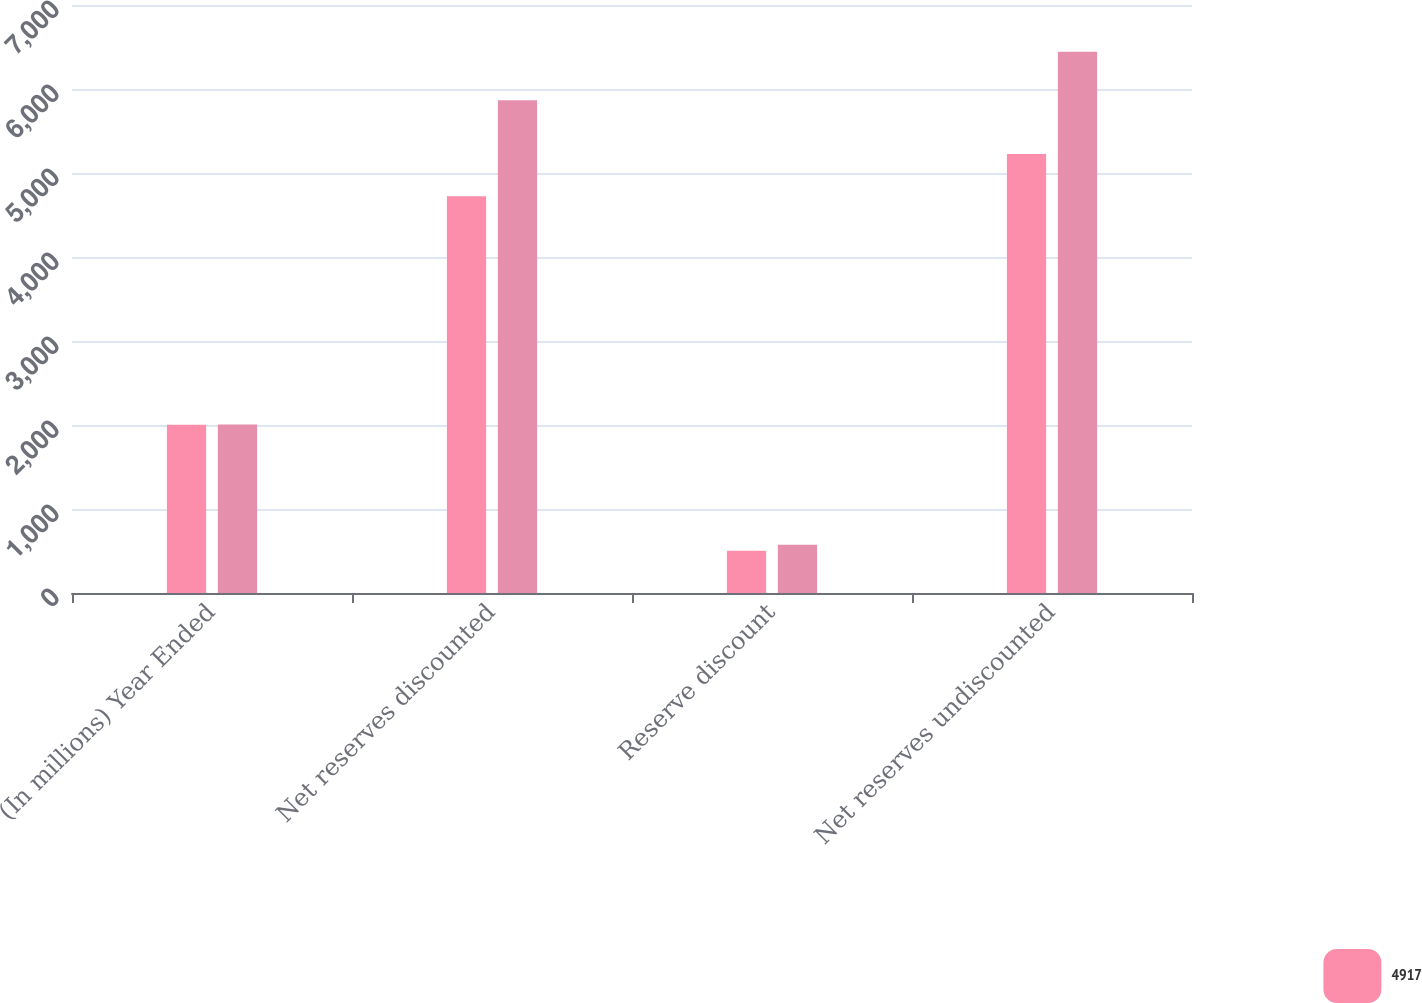Convert chart to OTSL. <chart><loc_0><loc_0><loc_500><loc_500><stacked_bar_chart><ecel><fcel>(In millions) Year Ended<fcel>Net reserves discounted<fcel>Reserve discount<fcel>Net reserves undiscounted<nl><fcel>4917<fcel>2004<fcel>4723<fcel>503<fcel>5226<nl><fcel>nan<fcel>2005<fcel>5867<fcel>575<fcel>6442<nl></chart> 